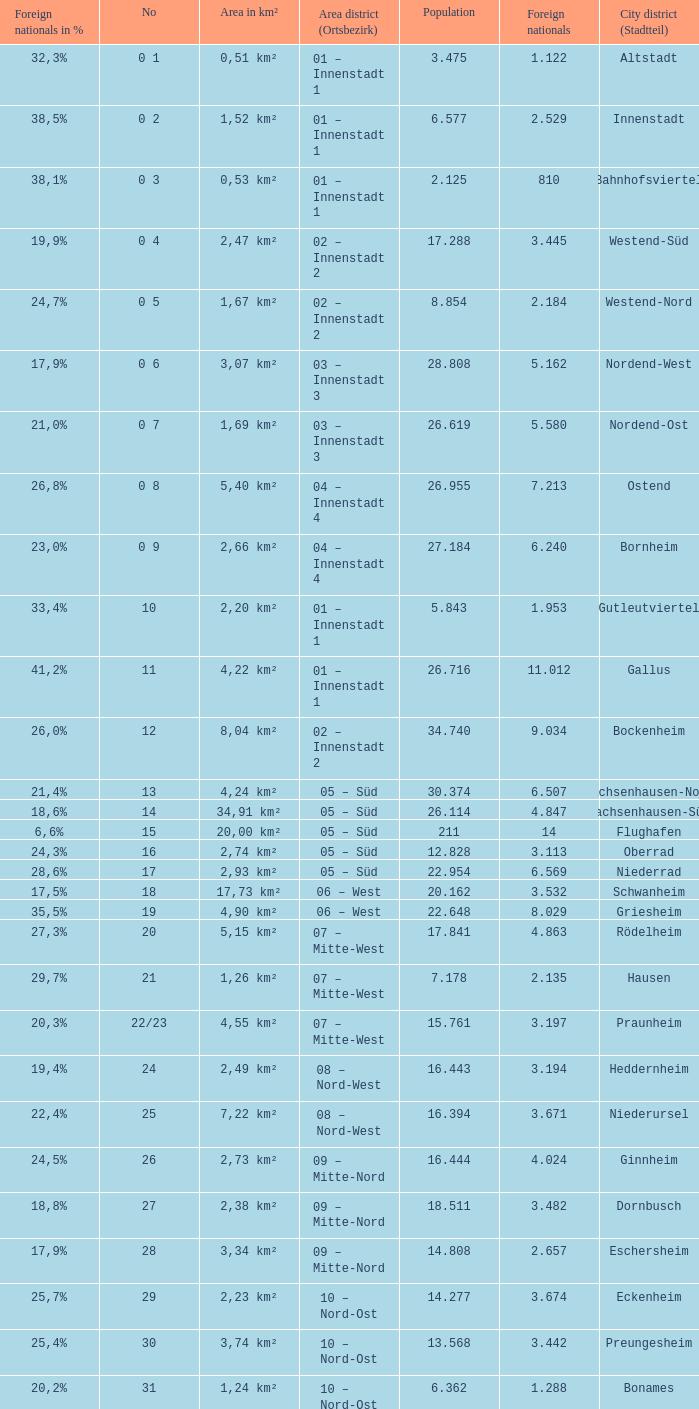What is the number of the city district of stadtteil where foreigners are 5.162? 1.0. 